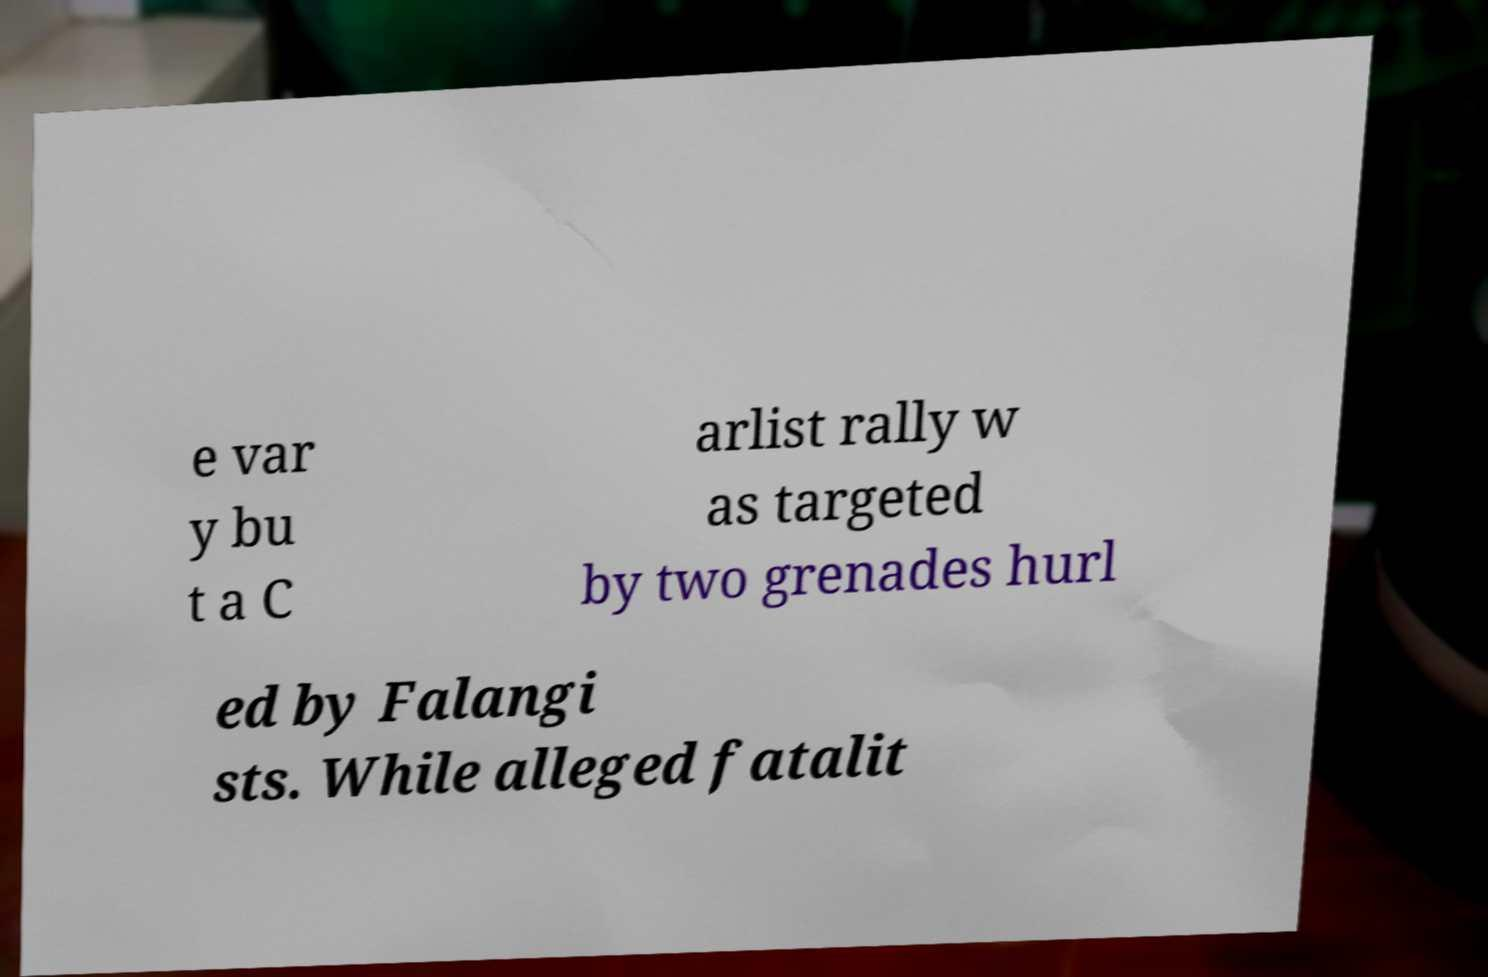There's text embedded in this image that I need extracted. Can you transcribe it verbatim? e var y bu t a C arlist rally w as targeted by two grenades hurl ed by Falangi sts. While alleged fatalit 